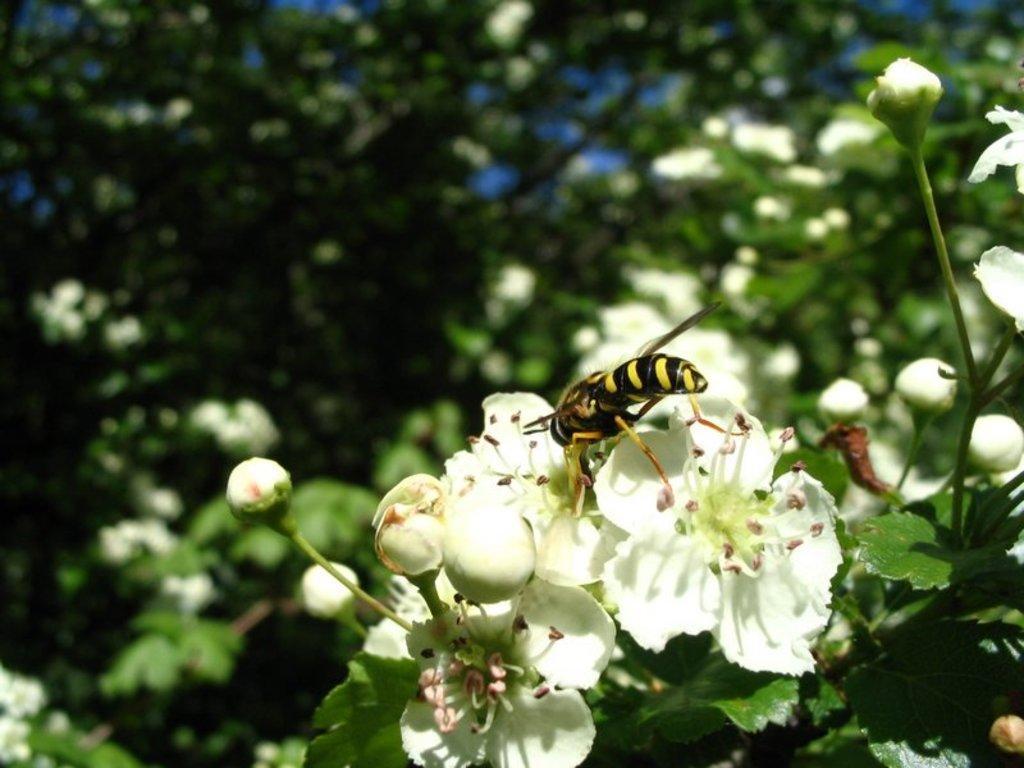Please provide a concise description of this image. These are the bunch of flowers and buds, which are white in color. This looks like a honey bee, which is on the flower. In the background, I can see the trees with leaves and flowers. 